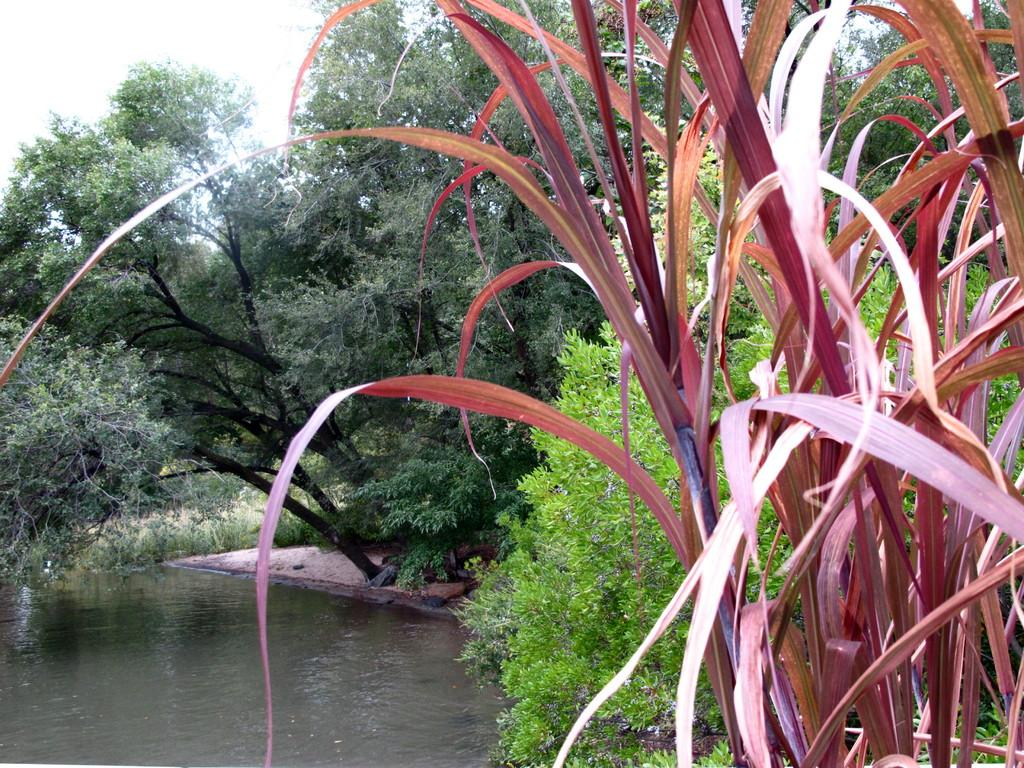What type of vegetation can be seen in the image? There are trees and plants in the image. Where is the lake located in the image? The lake is on the bottom left side of the image. How many oranges are hanging from the trees in the image? There are no oranges present in the image; it features trees and plants without any fruit. What type of rail can be seen in the image? There is no rail present in the image; it only contains trees, plants, and a lake. 